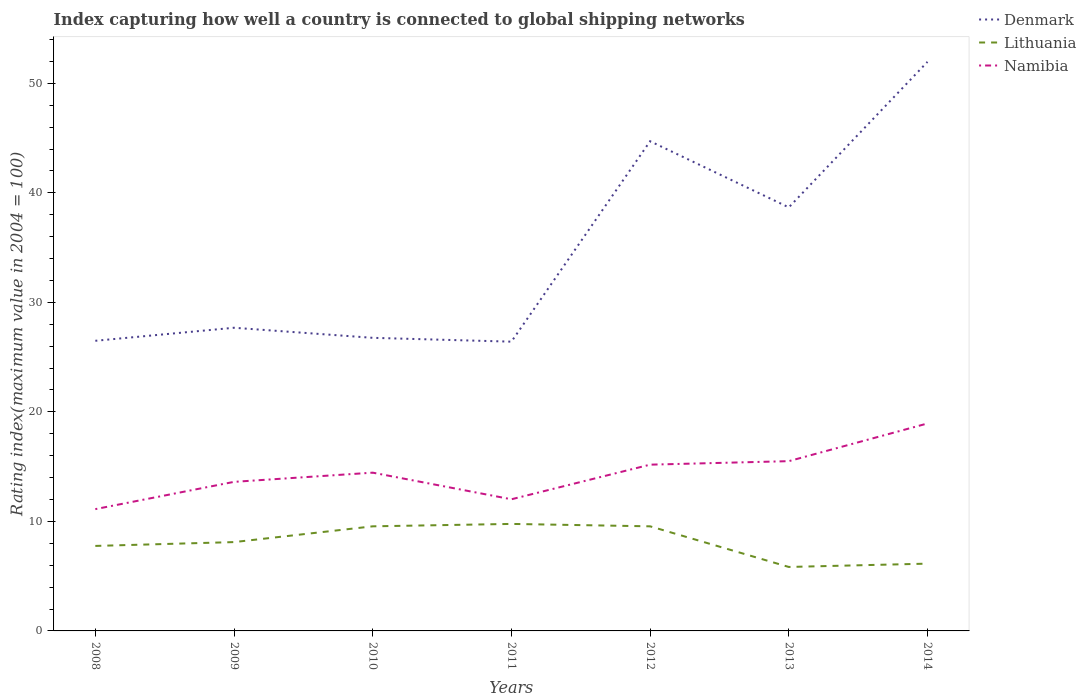Across all years, what is the maximum rating index in Namibia?
Offer a terse response. 11.12. What is the total rating index in Namibia in the graph?
Your response must be concise. -0.32. What is the difference between the highest and the second highest rating index in Denmark?
Ensure brevity in your answer.  25.55. How many lines are there?
Provide a succinct answer. 3. What is the difference between two consecutive major ticks on the Y-axis?
Ensure brevity in your answer.  10. Are the values on the major ticks of Y-axis written in scientific E-notation?
Ensure brevity in your answer.  No. Does the graph contain grids?
Offer a very short reply. No. How are the legend labels stacked?
Ensure brevity in your answer.  Vertical. What is the title of the graph?
Offer a very short reply. Index capturing how well a country is connected to global shipping networks. Does "Liberia" appear as one of the legend labels in the graph?
Your answer should be compact. No. What is the label or title of the Y-axis?
Make the answer very short. Rating index(maximum value in 2004 = 100). What is the Rating index(maximum value in 2004 = 100) in Denmark in 2008?
Offer a terse response. 26.49. What is the Rating index(maximum value in 2004 = 100) in Lithuania in 2008?
Ensure brevity in your answer.  7.76. What is the Rating index(maximum value in 2004 = 100) of Namibia in 2008?
Your response must be concise. 11.12. What is the Rating index(maximum value in 2004 = 100) in Denmark in 2009?
Your answer should be compact. 27.68. What is the Rating index(maximum value in 2004 = 100) of Lithuania in 2009?
Offer a very short reply. 8.11. What is the Rating index(maximum value in 2004 = 100) of Namibia in 2009?
Your response must be concise. 13.61. What is the Rating index(maximum value in 2004 = 100) in Denmark in 2010?
Your response must be concise. 26.76. What is the Rating index(maximum value in 2004 = 100) of Lithuania in 2010?
Give a very brief answer. 9.55. What is the Rating index(maximum value in 2004 = 100) in Namibia in 2010?
Your answer should be very brief. 14.45. What is the Rating index(maximum value in 2004 = 100) of Denmark in 2011?
Make the answer very short. 26.41. What is the Rating index(maximum value in 2004 = 100) in Lithuania in 2011?
Your answer should be compact. 9.77. What is the Rating index(maximum value in 2004 = 100) of Namibia in 2011?
Make the answer very short. 12.02. What is the Rating index(maximum value in 2004 = 100) in Denmark in 2012?
Keep it short and to the point. 44.71. What is the Rating index(maximum value in 2004 = 100) in Lithuania in 2012?
Provide a succinct answer. 9.55. What is the Rating index(maximum value in 2004 = 100) of Namibia in 2012?
Offer a very short reply. 15.18. What is the Rating index(maximum value in 2004 = 100) of Denmark in 2013?
Provide a succinct answer. 38.67. What is the Rating index(maximum value in 2004 = 100) of Lithuania in 2013?
Provide a short and direct response. 5.84. What is the Rating index(maximum value in 2004 = 100) of Denmark in 2014?
Offer a very short reply. 51.96. What is the Rating index(maximum value in 2004 = 100) of Lithuania in 2014?
Provide a succinct answer. 6.14. What is the Rating index(maximum value in 2004 = 100) of Namibia in 2014?
Give a very brief answer. 18.94. Across all years, what is the maximum Rating index(maximum value in 2004 = 100) in Denmark?
Your answer should be compact. 51.96. Across all years, what is the maximum Rating index(maximum value in 2004 = 100) of Lithuania?
Offer a terse response. 9.77. Across all years, what is the maximum Rating index(maximum value in 2004 = 100) in Namibia?
Provide a short and direct response. 18.94. Across all years, what is the minimum Rating index(maximum value in 2004 = 100) of Denmark?
Ensure brevity in your answer.  26.41. Across all years, what is the minimum Rating index(maximum value in 2004 = 100) in Lithuania?
Offer a very short reply. 5.84. Across all years, what is the minimum Rating index(maximum value in 2004 = 100) in Namibia?
Provide a succinct answer. 11.12. What is the total Rating index(maximum value in 2004 = 100) in Denmark in the graph?
Ensure brevity in your answer.  242.68. What is the total Rating index(maximum value in 2004 = 100) in Lithuania in the graph?
Provide a short and direct response. 56.72. What is the total Rating index(maximum value in 2004 = 100) of Namibia in the graph?
Ensure brevity in your answer.  100.82. What is the difference between the Rating index(maximum value in 2004 = 100) of Denmark in 2008 and that in 2009?
Provide a succinct answer. -1.19. What is the difference between the Rating index(maximum value in 2004 = 100) of Lithuania in 2008 and that in 2009?
Make the answer very short. -0.35. What is the difference between the Rating index(maximum value in 2004 = 100) of Namibia in 2008 and that in 2009?
Make the answer very short. -2.49. What is the difference between the Rating index(maximum value in 2004 = 100) in Denmark in 2008 and that in 2010?
Your answer should be compact. -0.27. What is the difference between the Rating index(maximum value in 2004 = 100) in Lithuania in 2008 and that in 2010?
Ensure brevity in your answer.  -1.79. What is the difference between the Rating index(maximum value in 2004 = 100) in Namibia in 2008 and that in 2010?
Provide a succinct answer. -3.33. What is the difference between the Rating index(maximum value in 2004 = 100) of Lithuania in 2008 and that in 2011?
Keep it short and to the point. -2.01. What is the difference between the Rating index(maximum value in 2004 = 100) in Namibia in 2008 and that in 2011?
Your answer should be very brief. -0.9. What is the difference between the Rating index(maximum value in 2004 = 100) of Denmark in 2008 and that in 2012?
Make the answer very short. -18.22. What is the difference between the Rating index(maximum value in 2004 = 100) of Lithuania in 2008 and that in 2012?
Your answer should be compact. -1.79. What is the difference between the Rating index(maximum value in 2004 = 100) in Namibia in 2008 and that in 2012?
Ensure brevity in your answer.  -4.06. What is the difference between the Rating index(maximum value in 2004 = 100) of Denmark in 2008 and that in 2013?
Offer a terse response. -12.18. What is the difference between the Rating index(maximum value in 2004 = 100) of Lithuania in 2008 and that in 2013?
Make the answer very short. 1.92. What is the difference between the Rating index(maximum value in 2004 = 100) in Namibia in 2008 and that in 2013?
Your response must be concise. -4.38. What is the difference between the Rating index(maximum value in 2004 = 100) of Denmark in 2008 and that in 2014?
Offer a very short reply. -25.47. What is the difference between the Rating index(maximum value in 2004 = 100) of Lithuania in 2008 and that in 2014?
Your response must be concise. 1.62. What is the difference between the Rating index(maximum value in 2004 = 100) of Namibia in 2008 and that in 2014?
Provide a short and direct response. -7.82. What is the difference between the Rating index(maximum value in 2004 = 100) in Lithuania in 2009 and that in 2010?
Offer a very short reply. -1.44. What is the difference between the Rating index(maximum value in 2004 = 100) in Namibia in 2009 and that in 2010?
Keep it short and to the point. -0.84. What is the difference between the Rating index(maximum value in 2004 = 100) of Denmark in 2009 and that in 2011?
Make the answer very short. 1.27. What is the difference between the Rating index(maximum value in 2004 = 100) in Lithuania in 2009 and that in 2011?
Your response must be concise. -1.66. What is the difference between the Rating index(maximum value in 2004 = 100) in Namibia in 2009 and that in 2011?
Give a very brief answer. 1.59. What is the difference between the Rating index(maximum value in 2004 = 100) in Denmark in 2009 and that in 2012?
Give a very brief answer. -17.03. What is the difference between the Rating index(maximum value in 2004 = 100) in Lithuania in 2009 and that in 2012?
Provide a short and direct response. -1.44. What is the difference between the Rating index(maximum value in 2004 = 100) of Namibia in 2009 and that in 2012?
Offer a terse response. -1.57. What is the difference between the Rating index(maximum value in 2004 = 100) of Denmark in 2009 and that in 2013?
Your answer should be compact. -10.99. What is the difference between the Rating index(maximum value in 2004 = 100) of Lithuania in 2009 and that in 2013?
Provide a succinct answer. 2.27. What is the difference between the Rating index(maximum value in 2004 = 100) of Namibia in 2009 and that in 2013?
Give a very brief answer. -1.89. What is the difference between the Rating index(maximum value in 2004 = 100) in Denmark in 2009 and that in 2014?
Your answer should be compact. -24.28. What is the difference between the Rating index(maximum value in 2004 = 100) in Lithuania in 2009 and that in 2014?
Your answer should be compact. 1.97. What is the difference between the Rating index(maximum value in 2004 = 100) of Namibia in 2009 and that in 2014?
Make the answer very short. -5.33. What is the difference between the Rating index(maximum value in 2004 = 100) of Denmark in 2010 and that in 2011?
Keep it short and to the point. 0.35. What is the difference between the Rating index(maximum value in 2004 = 100) of Lithuania in 2010 and that in 2011?
Your response must be concise. -0.22. What is the difference between the Rating index(maximum value in 2004 = 100) of Namibia in 2010 and that in 2011?
Your response must be concise. 2.43. What is the difference between the Rating index(maximum value in 2004 = 100) of Denmark in 2010 and that in 2012?
Offer a terse response. -17.95. What is the difference between the Rating index(maximum value in 2004 = 100) in Lithuania in 2010 and that in 2012?
Offer a very short reply. 0. What is the difference between the Rating index(maximum value in 2004 = 100) of Namibia in 2010 and that in 2012?
Provide a succinct answer. -0.73. What is the difference between the Rating index(maximum value in 2004 = 100) of Denmark in 2010 and that in 2013?
Offer a very short reply. -11.91. What is the difference between the Rating index(maximum value in 2004 = 100) in Lithuania in 2010 and that in 2013?
Offer a very short reply. 3.71. What is the difference between the Rating index(maximum value in 2004 = 100) of Namibia in 2010 and that in 2013?
Ensure brevity in your answer.  -1.05. What is the difference between the Rating index(maximum value in 2004 = 100) of Denmark in 2010 and that in 2014?
Your response must be concise. -25.2. What is the difference between the Rating index(maximum value in 2004 = 100) in Lithuania in 2010 and that in 2014?
Your answer should be very brief. 3.41. What is the difference between the Rating index(maximum value in 2004 = 100) of Namibia in 2010 and that in 2014?
Provide a succinct answer. -4.49. What is the difference between the Rating index(maximum value in 2004 = 100) of Denmark in 2011 and that in 2012?
Ensure brevity in your answer.  -18.3. What is the difference between the Rating index(maximum value in 2004 = 100) in Lithuania in 2011 and that in 2012?
Keep it short and to the point. 0.22. What is the difference between the Rating index(maximum value in 2004 = 100) in Namibia in 2011 and that in 2012?
Your answer should be very brief. -3.16. What is the difference between the Rating index(maximum value in 2004 = 100) in Denmark in 2011 and that in 2013?
Give a very brief answer. -12.26. What is the difference between the Rating index(maximum value in 2004 = 100) in Lithuania in 2011 and that in 2013?
Your response must be concise. 3.93. What is the difference between the Rating index(maximum value in 2004 = 100) of Namibia in 2011 and that in 2013?
Ensure brevity in your answer.  -3.48. What is the difference between the Rating index(maximum value in 2004 = 100) in Denmark in 2011 and that in 2014?
Your answer should be compact. -25.55. What is the difference between the Rating index(maximum value in 2004 = 100) of Lithuania in 2011 and that in 2014?
Provide a succinct answer. 3.63. What is the difference between the Rating index(maximum value in 2004 = 100) of Namibia in 2011 and that in 2014?
Ensure brevity in your answer.  -6.92. What is the difference between the Rating index(maximum value in 2004 = 100) in Denmark in 2012 and that in 2013?
Provide a succinct answer. 6.04. What is the difference between the Rating index(maximum value in 2004 = 100) in Lithuania in 2012 and that in 2013?
Make the answer very short. 3.71. What is the difference between the Rating index(maximum value in 2004 = 100) of Namibia in 2012 and that in 2013?
Your response must be concise. -0.32. What is the difference between the Rating index(maximum value in 2004 = 100) in Denmark in 2012 and that in 2014?
Give a very brief answer. -7.25. What is the difference between the Rating index(maximum value in 2004 = 100) in Lithuania in 2012 and that in 2014?
Your response must be concise. 3.41. What is the difference between the Rating index(maximum value in 2004 = 100) of Namibia in 2012 and that in 2014?
Offer a terse response. -3.76. What is the difference between the Rating index(maximum value in 2004 = 100) of Denmark in 2013 and that in 2014?
Ensure brevity in your answer.  -13.29. What is the difference between the Rating index(maximum value in 2004 = 100) in Lithuania in 2013 and that in 2014?
Provide a succinct answer. -0.3. What is the difference between the Rating index(maximum value in 2004 = 100) in Namibia in 2013 and that in 2014?
Offer a terse response. -3.44. What is the difference between the Rating index(maximum value in 2004 = 100) in Denmark in 2008 and the Rating index(maximum value in 2004 = 100) in Lithuania in 2009?
Your answer should be very brief. 18.38. What is the difference between the Rating index(maximum value in 2004 = 100) of Denmark in 2008 and the Rating index(maximum value in 2004 = 100) of Namibia in 2009?
Your answer should be compact. 12.88. What is the difference between the Rating index(maximum value in 2004 = 100) in Lithuania in 2008 and the Rating index(maximum value in 2004 = 100) in Namibia in 2009?
Provide a succinct answer. -5.85. What is the difference between the Rating index(maximum value in 2004 = 100) of Denmark in 2008 and the Rating index(maximum value in 2004 = 100) of Lithuania in 2010?
Provide a short and direct response. 16.94. What is the difference between the Rating index(maximum value in 2004 = 100) in Denmark in 2008 and the Rating index(maximum value in 2004 = 100) in Namibia in 2010?
Your response must be concise. 12.04. What is the difference between the Rating index(maximum value in 2004 = 100) of Lithuania in 2008 and the Rating index(maximum value in 2004 = 100) of Namibia in 2010?
Provide a succinct answer. -6.69. What is the difference between the Rating index(maximum value in 2004 = 100) of Denmark in 2008 and the Rating index(maximum value in 2004 = 100) of Lithuania in 2011?
Offer a very short reply. 16.72. What is the difference between the Rating index(maximum value in 2004 = 100) in Denmark in 2008 and the Rating index(maximum value in 2004 = 100) in Namibia in 2011?
Give a very brief answer. 14.47. What is the difference between the Rating index(maximum value in 2004 = 100) of Lithuania in 2008 and the Rating index(maximum value in 2004 = 100) of Namibia in 2011?
Offer a terse response. -4.26. What is the difference between the Rating index(maximum value in 2004 = 100) in Denmark in 2008 and the Rating index(maximum value in 2004 = 100) in Lithuania in 2012?
Provide a short and direct response. 16.94. What is the difference between the Rating index(maximum value in 2004 = 100) of Denmark in 2008 and the Rating index(maximum value in 2004 = 100) of Namibia in 2012?
Your response must be concise. 11.31. What is the difference between the Rating index(maximum value in 2004 = 100) of Lithuania in 2008 and the Rating index(maximum value in 2004 = 100) of Namibia in 2012?
Your response must be concise. -7.42. What is the difference between the Rating index(maximum value in 2004 = 100) in Denmark in 2008 and the Rating index(maximum value in 2004 = 100) in Lithuania in 2013?
Give a very brief answer. 20.65. What is the difference between the Rating index(maximum value in 2004 = 100) in Denmark in 2008 and the Rating index(maximum value in 2004 = 100) in Namibia in 2013?
Offer a terse response. 10.99. What is the difference between the Rating index(maximum value in 2004 = 100) of Lithuania in 2008 and the Rating index(maximum value in 2004 = 100) of Namibia in 2013?
Keep it short and to the point. -7.74. What is the difference between the Rating index(maximum value in 2004 = 100) of Denmark in 2008 and the Rating index(maximum value in 2004 = 100) of Lithuania in 2014?
Offer a terse response. 20.35. What is the difference between the Rating index(maximum value in 2004 = 100) of Denmark in 2008 and the Rating index(maximum value in 2004 = 100) of Namibia in 2014?
Your answer should be very brief. 7.55. What is the difference between the Rating index(maximum value in 2004 = 100) in Lithuania in 2008 and the Rating index(maximum value in 2004 = 100) in Namibia in 2014?
Keep it short and to the point. -11.18. What is the difference between the Rating index(maximum value in 2004 = 100) of Denmark in 2009 and the Rating index(maximum value in 2004 = 100) of Lithuania in 2010?
Make the answer very short. 18.13. What is the difference between the Rating index(maximum value in 2004 = 100) in Denmark in 2009 and the Rating index(maximum value in 2004 = 100) in Namibia in 2010?
Keep it short and to the point. 13.23. What is the difference between the Rating index(maximum value in 2004 = 100) of Lithuania in 2009 and the Rating index(maximum value in 2004 = 100) of Namibia in 2010?
Offer a very short reply. -6.34. What is the difference between the Rating index(maximum value in 2004 = 100) in Denmark in 2009 and the Rating index(maximum value in 2004 = 100) in Lithuania in 2011?
Your answer should be very brief. 17.91. What is the difference between the Rating index(maximum value in 2004 = 100) of Denmark in 2009 and the Rating index(maximum value in 2004 = 100) of Namibia in 2011?
Ensure brevity in your answer.  15.66. What is the difference between the Rating index(maximum value in 2004 = 100) of Lithuania in 2009 and the Rating index(maximum value in 2004 = 100) of Namibia in 2011?
Provide a short and direct response. -3.91. What is the difference between the Rating index(maximum value in 2004 = 100) of Denmark in 2009 and the Rating index(maximum value in 2004 = 100) of Lithuania in 2012?
Keep it short and to the point. 18.13. What is the difference between the Rating index(maximum value in 2004 = 100) of Lithuania in 2009 and the Rating index(maximum value in 2004 = 100) of Namibia in 2012?
Provide a short and direct response. -7.07. What is the difference between the Rating index(maximum value in 2004 = 100) in Denmark in 2009 and the Rating index(maximum value in 2004 = 100) in Lithuania in 2013?
Offer a very short reply. 21.84. What is the difference between the Rating index(maximum value in 2004 = 100) of Denmark in 2009 and the Rating index(maximum value in 2004 = 100) of Namibia in 2013?
Give a very brief answer. 12.18. What is the difference between the Rating index(maximum value in 2004 = 100) of Lithuania in 2009 and the Rating index(maximum value in 2004 = 100) of Namibia in 2013?
Keep it short and to the point. -7.39. What is the difference between the Rating index(maximum value in 2004 = 100) of Denmark in 2009 and the Rating index(maximum value in 2004 = 100) of Lithuania in 2014?
Keep it short and to the point. 21.54. What is the difference between the Rating index(maximum value in 2004 = 100) in Denmark in 2009 and the Rating index(maximum value in 2004 = 100) in Namibia in 2014?
Provide a succinct answer. 8.74. What is the difference between the Rating index(maximum value in 2004 = 100) in Lithuania in 2009 and the Rating index(maximum value in 2004 = 100) in Namibia in 2014?
Your answer should be compact. -10.83. What is the difference between the Rating index(maximum value in 2004 = 100) of Denmark in 2010 and the Rating index(maximum value in 2004 = 100) of Lithuania in 2011?
Offer a terse response. 16.99. What is the difference between the Rating index(maximum value in 2004 = 100) of Denmark in 2010 and the Rating index(maximum value in 2004 = 100) of Namibia in 2011?
Keep it short and to the point. 14.74. What is the difference between the Rating index(maximum value in 2004 = 100) in Lithuania in 2010 and the Rating index(maximum value in 2004 = 100) in Namibia in 2011?
Keep it short and to the point. -2.47. What is the difference between the Rating index(maximum value in 2004 = 100) of Denmark in 2010 and the Rating index(maximum value in 2004 = 100) of Lithuania in 2012?
Ensure brevity in your answer.  17.21. What is the difference between the Rating index(maximum value in 2004 = 100) in Denmark in 2010 and the Rating index(maximum value in 2004 = 100) in Namibia in 2012?
Your response must be concise. 11.58. What is the difference between the Rating index(maximum value in 2004 = 100) of Lithuania in 2010 and the Rating index(maximum value in 2004 = 100) of Namibia in 2012?
Provide a short and direct response. -5.63. What is the difference between the Rating index(maximum value in 2004 = 100) in Denmark in 2010 and the Rating index(maximum value in 2004 = 100) in Lithuania in 2013?
Your response must be concise. 20.92. What is the difference between the Rating index(maximum value in 2004 = 100) in Denmark in 2010 and the Rating index(maximum value in 2004 = 100) in Namibia in 2013?
Your answer should be very brief. 11.26. What is the difference between the Rating index(maximum value in 2004 = 100) in Lithuania in 2010 and the Rating index(maximum value in 2004 = 100) in Namibia in 2013?
Give a very brief answer. -5.95. What is the difference between the Rating index(maximum value in 2004 = 100) of Denmark in 2010 and the Rating index(maximum value in 2004 = 100) of Lithuania in 2014?
Ensure brevity in your answer.  20.62. What is the difference between the Rating index(maximum value in 2004 = 100) of Denmark in 2010 and the Rating index(maximum value in 2004 = 100) of Namibia in 2014?
Your response must be concise. 7.82. What is the difference between the Rating index(maximum value in 2004 = 100) of Lithuania in 2010 and the Rating index(maximum value in 2004 = 100) of Namibia in 2014?
Provide a short and direct response. -9.39. What is the difference between the Rating index(maximum value in 2004 = 100) in Denmark in 2011 and the Rating index(maximum value in 2004 = 100) in Lithuania in 2012?
Provide a short and direct response. 16.86. What is the difference between the Rating index(maximum value in 2004 = 100) in Denmark in 2011 and the Rating index(maximum value in 2004 = 100) in Namibia in 2012?
Provide a succinct answer. 11.23. What is the difference between the Rating index(maximum value in 2004 = 100) in Lithuania in 2011 and the Rating index(maximum value in 2004 = 100) in Namibia in 2012?
Offer a terse response. -5.41. What is the difference between the Rating index(maximum value in 2004 = 100) in Denmark in 2011 and the Rating index(maximum value in 2004 = 100) in Lithuania in 2013?
Offer a very short reply. 20.57. What is the difference between the Rating index(maximum value in 2004 = 100) in Denmark in 2011 and the Rating index(maximum value in 2004 = 100) in Namibia in 2013?
Make the answer very short. 10.91. What is the difference between the Rating index(maximum value in 2004 = 100) of Lithuania in 2011 and the Rating index(maximum value in 2004 = 100) of Namibia in 2013?
Give a very brief answer. -5.73. What is the difference between the Rating index(maximum value in 2004 = 100) in Denmark in 2011 and the Rating index(maximum value in 2004 = 100) in Lithuania in 2014?
Your response must be concise. 20.27. What is the difference between the Rating index(maximum value in 2004 = 100) in Denmark in 2011 and the Rating index(maximum value in 2004 = 100) in Namibia in 2014?
Your answer should be compact. 7.47. What is the difference between the Rating index(maximum value in 2004 = 100) of Lithuania in 2011 and the Rating index(maximum value in 2004 = 100) of Namibia in 2014?
Give a very brief answer. -9.17. What is the difference between the Rating index(maximum value in 2004 = 100) in Denmark in 2012 and the Rating index(maximum value in 2004 = 100) in Lithuania in 2013?
Make the answer very short. 38.87. What is the difference between the Rating index(maximum value in 2004 = 100) in Denmark in 2012 and the Rating index(maximum value in 2004 = 100) in Namibia in 2013?
Make the answer very short. 29.21. What is the difference between the Rating index(maximum value in 2004 = 100) in Lithuania in 2012 and the Rating index(maximum value in 2004 = 100) in Namibia in 2013?
Your answer should be compact. -5.95. What is the difference between the Rating index(maximum value in 2004 = 100) of Denmark in 2012 and the Rating index(maximum value in 2004 = 100) of Lithuania in 2014?
Offer a very short reply. 38.57. What is the difference between the Rating index(maximum value in 2004 = 100) of Denmark in 2012 and the Rating index(maximum value in 2004 = 100) of Namibia in 2014?
Ensure brevity in your answer.  25.77. What is the difference between the Rating index(maximum value in 2004 = 100) in Lithuania in 2012 and the Rating index(maximum value in 2004 = 100) in Namibia in 2014?
Your answer should be compact. -9.39. What is the difference between the Rating index(maximum value in 2004 = 100) of Denmark in 2013 and the Rating index(maximum value in 2004 = 100) of Lithuania in 2014?
Offer a terse response. 32.53. What is the difference between the Rating index(maximum value in 2004 = 100) in Denmark in 2013 and the Rating index(maximum value in 2004 = 100) in Namibia in 2014?
Offer a terse response. 19.73. What is the difference between the Rating index(maximum value in 2004 = 100) of Lithuania in 2013 and the Rating index(maximum value in 2004 = 100) of Namibia in 2014?
Offer a very short reply. -13.1. What is the average Rating index(maximum value in 2004 = 100) of Denmark per year?
Ensure brevity in your answer.  34.67. What is the average Rating index(maximum value in 2004 = 100) of Lithuania per year?
Your answer should be compact. 8.1. What is the average Rating index(maximum value in 2004 = 100) of Namibia per year?
Make the answer very short. 14.4. In the year 2008, what is the difference between the Rating index(maximum value in 2004 = 100) of Denmark and Rating index(maximum value in 2004 = 100) of Lithuania?
Provide a succinct answer. 18.73. In the year 2008, what is the difference between the Rating index(maximum value in 2004 = 100) of Denmark and Rating index(maximum value in 2004 = 100) of Namibia?
Your response must be concise. 15.37. In the year 2008, what is the difference between the Rating index(maximum value in 2004 = 100) in Lithuania and Rating index(maximum value in 2004 = 100) in Namibia?
Make the answer very short. -3.36. In the year 2009, what is the difference between the Rating index(maximum value in 2004 = 100) of Denmark and Rating index(maximum value in 2004 = 100) of Lithuania?
Give a very brief answer. 19.57. In the year 2009, what is the difference between the Rating index(maximum value in 2004 = 100) in Denmark and Rating index(maximum value in 2004 = 100) in Namibia?
Make the answer very short. 14.07. In the year 2010, what is the difference between the Rating index(maximum value in 2004 = 100) of Denmark and Rating index(maximum value in 2004 = 100) of Lithuania?
Your response must be concise. 17.21. In the year 2010, what is the difference between the Rating index(maximum value in 2004 = 100) of Denmark and Rating index(maximum value in 2004 = 100) of Namibia?
Provide a short and direct response. 12.31. In the year 2010, what is the difference between the Rating index(maximum value in 2004 = 100) of Lithuania and Rating index(maximum value in 2004 = 100) of Namibia?
Your response must be concise. -4.9. In the year 2011, what is the difference between the Rating index(maximum value in 2004 = 100) of Denmark and Rating index(maximum value in 2004 = 100) of Lithuania?
Offer a terse response. 16.64. In the year 2011, what is the difference between the Rating index(maximum value in 2004 = 100) of Denmark and Rating index(maximum value in 2004 = 100) of Namibia?
Offer a terse response. 14.39. In the year 2011, what is the difference between the Rating index(maximum value in 2004 = 100) of Lithuania and Rating index(maximum value in 2004 = 100) of Namibia?
Your answer should be very brief. -2.25. In the year 2012, what is the difference between the Rating index(maximum value in 2004 = 100) of Denmark and Rating index(maximum value in 2004 = 100) of Lithuania?
Ensure brevity in your answer.  35.16. In the year 2012, what is the difference between the Rating index(maximum value in 2004 = 100) in Denmark and Rating index(maximum value in 2004 = 100) in Namibia?
Your response must be concise. 29.53. In the year 2012, what is the difference between the Rating index(maximum value in 2004 = 100) of Lithuania and Rating index(maximum value in 2004 = 100) of Namibia?
Offer a very short reply. -5.63. In the year 2013, what is the difference between the Rating index(maximum value in 2004 = 100) in Denmark and Rating index(maximum value in 2004 = 100) in Lithuania?
Your answer should be compact. 32.83. In the year 2013, what is the difference between the Rating index(maximum value in 2004 = 100) in Denmark and Rating index(maximum value in 2004 = 100) in Namibia?
Your response must be concise. 23.17. In the year 2013, what is the difference between the Rating index(maximum value in 2004 = 100) in Lithuania and Rating index(maximum value in 2004 = 100) in Namibia?
Ensure brevity in your answer.  -9.66. In the year 2014, what is the difference between the Rating index(maximum value in 2004 = 100) of Denmark and Rating index(maximum value in 2004 = 100) of Lithuania?
Offer a terse response. 45.82. In the year 2014, what is the difference between the Rating index(maximum value in 2004 = 100) in Denmark and Rating index(maximum value in 2004 = 100) in Namibia?
Ensure brevity in your answer.  33.02. In the year 2014, what is the difference between the Rating index(maximum value in 2004 = 100) in Lithuania and Rating index(maximum value in 2004 = 100) in Namibia?
Offer a very short reply. -12.8. What is the ratio of the Rating index(maximum value in 2004 = 100) in Lithuania in 2008 to that in 2009?
Your answer should be compact. 0.96. What is the ratio of the Rating index(maximum value in 2004 = 100) of Namibia in 2008 to that in 2009?
Offer a terse response. 0.82. What is the ratio of the Rating index(maximum value in 2004 = 100) in Lithuania in 2008 to that in 2010?
Ensure brevity in your answer.  0.81. What is the ratio of the Rating index(maximum value in 2004 = 100) in Namibia in 2008 to that in 2010?
Provide a short and direct response. 0.77. What is the ratio of the Rating index(maximum value in 2004 = 100) in Denmark in 2008 to that in 2011?
Offer a very short reply. 1. What is the ratio of the Rating index(maximum value in 2004 = 100) in Lithuania in 2008 to that in 2011?
Provide a succinct answer. 0.79. What is the ratio of the Rating index(maximum value in 2004 = 100) of Namibia in 2008 to that in 2011?
Your answer should be compact. 0.93. What is the ratio of the Rating index(maximum value in 2004 = 100) in Denmark in 2008 to that in 2012?
Ensure brevity in your answer.  0.59. What is the ratio of the Rating index(maximum value in 2004 = 100) in Lithuania in 2008 to that in 2012?
Ensure brevity in your answer.  0.81. What is the ratio of the Rating index(maximum value in 2004 = 100) in Namibia in 2008 to that in 2012?
Keep it short and to the point. 0.73. What is the ratio of the Rating index(maximum value in 2004 = 100) in Denmark in 2008 to that in 2013?
Offer a terse response. 0.69. What is the ratio of the Rating index(maximum value in 2004 = 100) in Lithuania in 2008 to that in 2013?
Provide a short and direct response. 1.33. What is the ratio of the Rating index(maximum value in 2004 = 100) of Namibia in 2008 to that in 2013?
Make the answer very short. 0.72. What is the ratio of the Rating index(maximum value in 2004 = 100) in Denmark in 2008 to that in 2014?
Your answer should be compact. 0.51. What is the ratio of the Rating index(maximum value in 2004 = 100) in Lithuania in 2008 to that in 2014?
Your answer should be very brief. 1.26. What is the ratio of the Rating index(maximum value in 2004 = 100) of Namibia in 2008 to that in 2014?
Ensure brevity in your answer.  0.59. What is the ratio of the Rating index(maximum value in 2004 = 100) in Denmark in 2009 to that in 2010?
Provide a succinct answer. 1.03. What is the ratio of the Rating index(maximum value in 2004 = 100) of Lithuania in 2009 to that in 2010?
Keep it short and to the point. 0.85. What is the ratio of the Rating index(maximum value in 2004 = 100) in Namibia in 2009 to that in 2010?
Your answer should be compact. 0.94. What is the ratio of the Rating index(maximum value in 2004 = 100) of Denmark in 2009 to that in 2011?
Your response must be concise. 1.05. What is the ratio of the Rating index(maximum value in 2004 = 100) of Lithuania in 2009 to that in 2011?
Offer a very short reply. 0.83. What is the ratio of the Rating index(maximum value in 2004 = 100) in Namibia in 2009 to that in 2011?
Your answer should be compact. 1.13. What is the ratio of the Rating index(maximum value in 2004 = 100) in Denmark in 2009 to that in 2012?
Provide a short and direct response. 0.62. What is the ratio of the Rating index(maximum value in 2004 = 100) of Lithuania in 2009 to that in 2012?
Your answer should be very brief. 0.85. What is the ratio of the Rating index(maximum value in 2004 = 100) in Namibia in 2009 to that in 2012?
Ensure brevity in your answer.  0.9. What is the ratio of the Rating index(maximum value in 2004 = 100) of Denmark in 2009 to that in 2013?
Offer a terse response. 0.72. What is the ratio of the Rating index(maximum value in 2004 = 100) of Lithuania in 2009 to that in 2013?
Ensure brevity in your answer.  1.39. What is the ratio of the Rating index(maximum value in 2004 = 100) in Namibia in 2009 to that in 2013?
Your answer should be very brief. 0.88. What is the ratio of the Rating index(maximum value in 2004 = 100) of Denmark in 2009 to that in 2014?
Offer a very short reply. 0.53. What is the ratio of the Rating index(maximum value in 2004 = 100) in Lithuania in 2009 to that in 2014?
Your answer should be very brief. 1.32. What is the ratio of the Rating index(maximum value in 2004 = 100) of Namibia in 2009 to that in 2014?
Your response must be concise. 0.72. What is the ratio of the Rating index(maximum value in 2004 = 100) in Denmark in 2010 to that in 2011?
Your answer should be very brief. 1.01. What is the ratio of the Rating index(maximum value in 2004 = 100) in Lithuania in 2010 to that in 2011?
Your response must be concise. 0.98. What is the ratio of the Rating index(maximum value in 2004 = 100) in Namibia in 2010 to that in 2011?
Provide a succinct answer. 1.2. What is the ratio of the Rating index(maximum value in 2004 = 100) of Denmark in 2010 to that in 2012?
Make the answer very short. 0.6. What is the ratio of the Rating index(maximum value in 2004 = 100) in Lithuania in 2010 to that in 2012?
Your response must be concise. 1. What is the ratio of the Rating index(maximum value in 2004 = 100) in Namibia in 2010 to that in 2012?
Offer a very short reply. 0.95. What is the ratio of the Rating index(maximum value in 2004 = 100) in Denmark in 2010 to that in 2013?
Ensure brevity in your answer.  0.69. What is the ratio of the Rating index(maximum value in 2004 = 100) of Lithuania in 2010 to that in 2013?
Offer a terse response. 1.64. What is the ratio of the Rating index(maximum value in 2004 = 100) in Namibia in 2010 to that in 2013?
Offer a terse response. 0.93. What is the ratio of the Rating index(maximum value in 2004 = 100) of Denmark in 2010 to that in 2014?
Your answer should be very brief. 0.52. What is the ratio of the Rating index(maximum value in 2004 = 100) of Lithuania in 2010 to that in 2014?
Your answer should be very brief. 1.55. What is the ratio of the Rating index(maximum value in 2004 = 100) in Namibia in 2010 to that in 2014?
Give a very brief answer. 0.76. What is the ratio of the Rating index(maximum value in 2004 = 100) of Denmark in 2011 to that in 2012?
Your answer should be very brief. 0.59. What is the ratio of the Rating index(maximum value in 2004 = 100) of Namibia in 2011 to that in 2012?
Your answer should be very brief. 0.79. What is the ratio of the Rating index(maximum value in 2004 = 100) in Denmark in 2011 to that in 2013?
Offer a very short reply. 0.68. What is the ratio of the Rating index(maximum value in 2004 = 100) in Lithuania in 2011 to that in 2013?
Your response must be concise. 1.67. What is the ratio of the Rating index(maximum value in 2004 = 100) of Namibia in 2011 to that in 2013?
Offer a very short reply. 0.78. What is the ratio of the Rating index(maximum value in 2004 = 100) of Denmark in 2011 to that in 2014?
Offer a terse response. 0.51. What is the ratio of the Rating index(maximum value in 2004 = 100) of Lithuania in 2011 to that in 2014?
Give a very brief answer. 1.59. What is the ratio of the Rating index(maximum value in 2004 = 100) in Namibia in 2011 to that in 2014?
Your answer should be very brief. 0.63. What is the ratio of the Rating index(maximum value in 2004 = 100) of Denmark in 2012 to that in 2013?
Make the answer very short. 1.16. What is the ratio of the Rating index(maximum value in 2004 = 100) in Lithuania in 2012 to that in 2013?
Your answer should be compact. 1.64. What is the ratio of the Rating index(maximum value in 2004 = 100) of Namibia in 2012 to that in 2013?
Your response must be concise. 0.98. What is the ratio of the Rating index(maximum value in 2004 = 100) of Denmark in 2012 to that in 2014?
Ensure brevity in your answer.  0.86. What is the ratio of the Rating index(maximum value in 2004 = 100) in Lithuania in 2012 to that in 2014?
Your answer should be very brief. 1.55. What is the ratio of the Rating index(maximum value in 2004 = 100) in Namibia in 2012 to that in 2014?
Offer a terse response. 0.8. What is the ratio of the Rating index(maximum value in 2004 = 100) in Denmark in 2013 to that in 2014?
Ensure brevity in your answer.  0.74. What is the ratio of the Rating index(maximum value in 2004 = 100) of Lithuania in 2013 to that in 2014?
Provide a succinct answer. 0.95. What is the ratio of the Rating index(maximum value in 2004 = 100) in Namibia in 2013 to that in 2014?
Provide a succinct answer. 0.82. What is the difference between the highest and the second highest Rating index(maximum value in 2004 = 100) of Denmark?
Ensure brevity in your answer.  7.25. What is the difference between the highest and the second highest Rating index(maximum value in 2004 = 100) in Lithuania?
Your answer should be very brief. 0.22. What is the difference between the highest and the second highest Rating index(maximum value in 2004 = 100) of Namibia?
Provide a succinct answer. 3.44. What is the difference between the highest and the lowest Rating index(maximum value in 2004 = 100) of Denmark?
Keep it short and to the point. 25.55. What is the difference between the highest and the lowest Rating index(maximum value in 2004 = 100) of Lithuania?
Your answer should be compact. 3.93. What is the difference between the highest and the lowest Rating index(maximum value in 2004 = 100) in Namibia?
Your answer should be very brief. 7.82. 